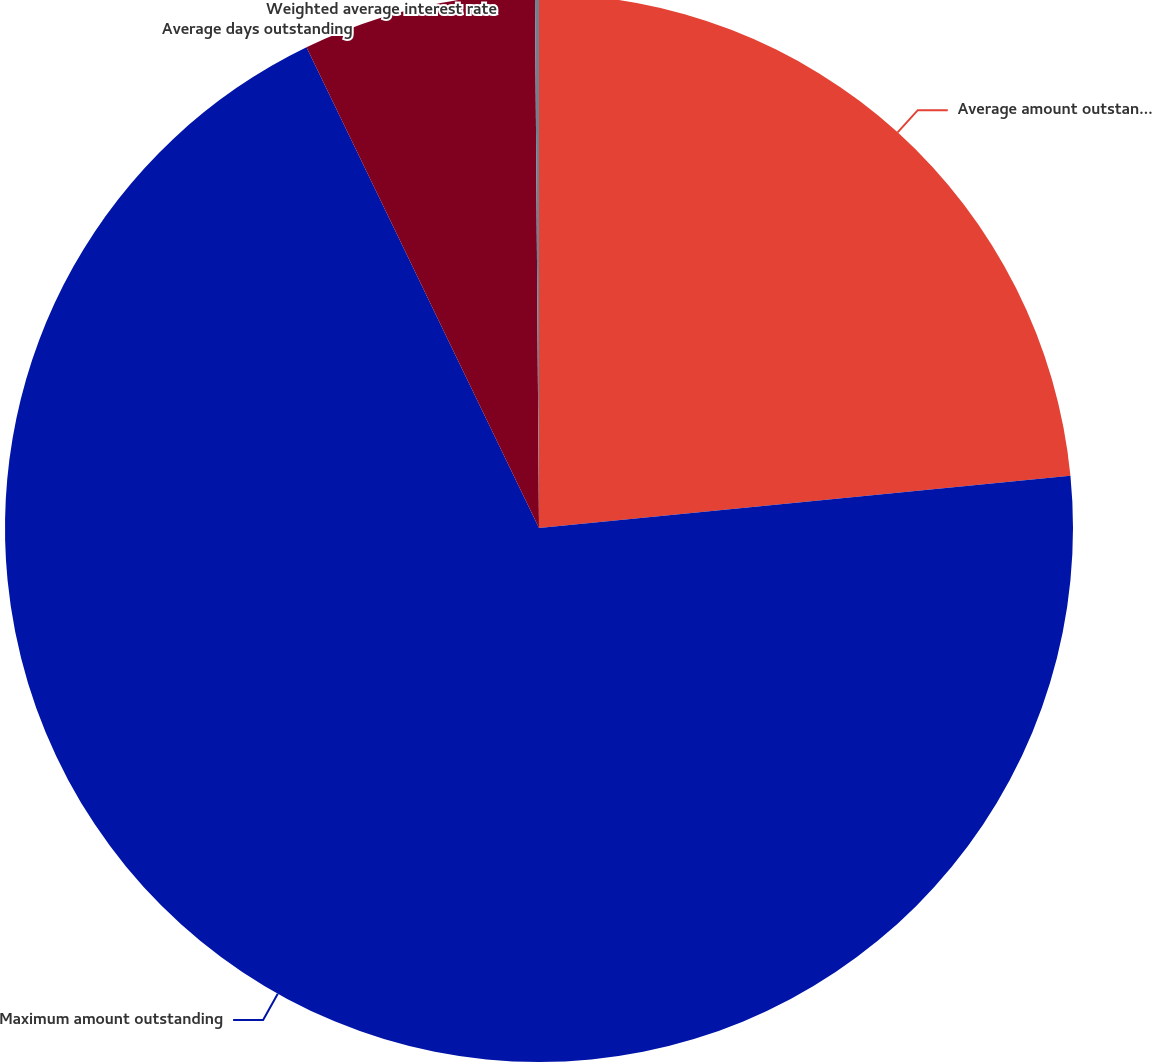Convert chart. <chart><loc_0><loc_0><loc_500><loc_500><pie_chart><fcel>Average amount outstanding<fcel>Maximum amount outstanding<fcel>Average days outstanding<fcel>Weighted average interest rate<nl><fcel>23.44%<fcel>69.39%<fcel>7.05%<fcel>0.12%<nl></chart> 